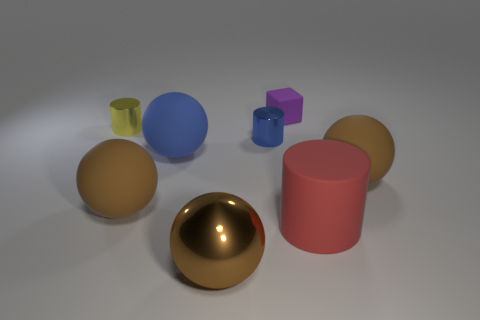How many other objects are there of the same color as the metal sphere?
Offer a terse response. 2. Are there any metallic things that have the same size as the red rubber cylinder?
Your answer should be compact. Yes. What is the material of the blue thing that is the same size as the matte cylinder?
Your response must be concise. Rubber. How many objects are either metal cylinders in front of the small yellow metal cylinder or spheres to the right of the small purple object?
Give a very brief answer. 2. Are there any other matte things that have the same shape as the tiny yellow thing?
Provide a succinct answer. Yes. What number of metallic objects are tiny cylinders or large yellow objects?
Ensure brevity in your answer.  2. What is the shape of the tiny purple matte object?
Make the answer very short. Cube. How many yellow cylinders are made of the same material as the large blue object?
Give a very brief answer. 0. The big ball that is the same material as the yellow cylinder is what color?
Keep it short and to the point. Brown. There is a matte sphere right of the purple thing; is its size the same as the blue metal cylinder?
Offer a very short reply. No. 